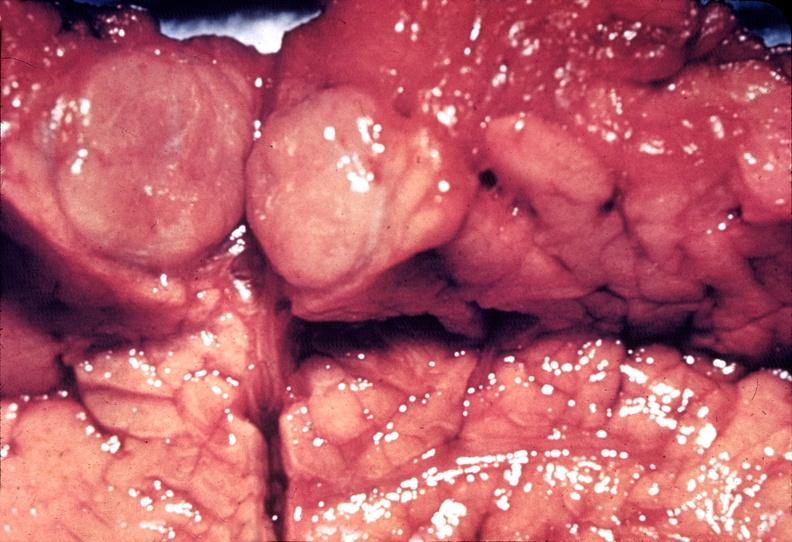what is present?
Answer the question using a single word or phrase. Pancreas 